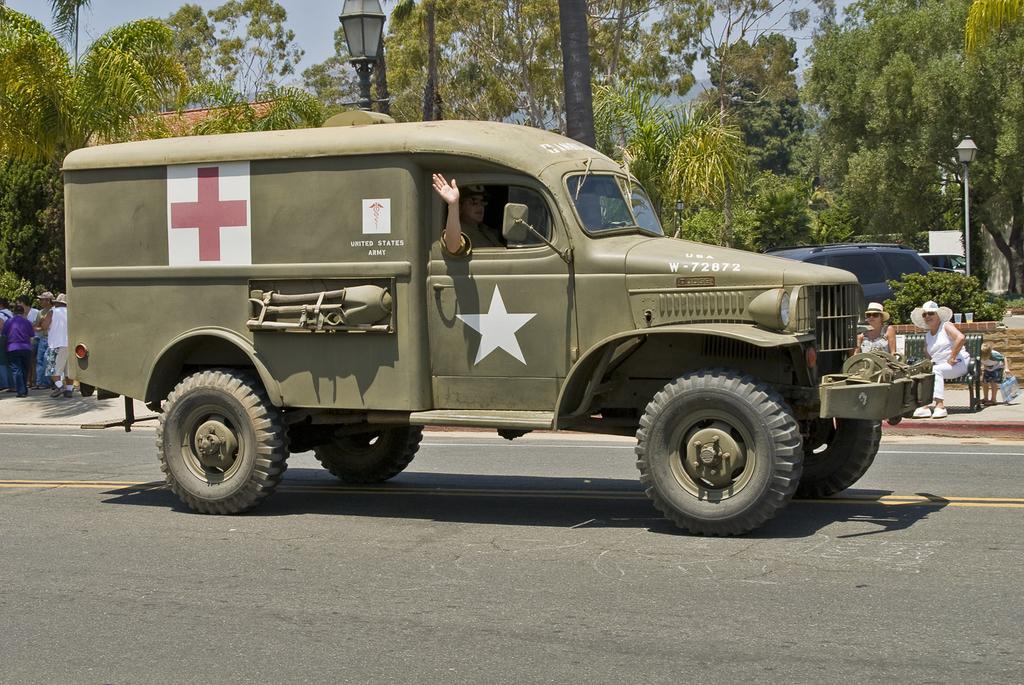Could you give a brief overview of what you see in this image? In this image there is a person sitting in the vehicle, which is on the road, behind the vehicle there are a few people standing on the path and few are sitting on the bench. In the background there is a building, trees and street lights. 